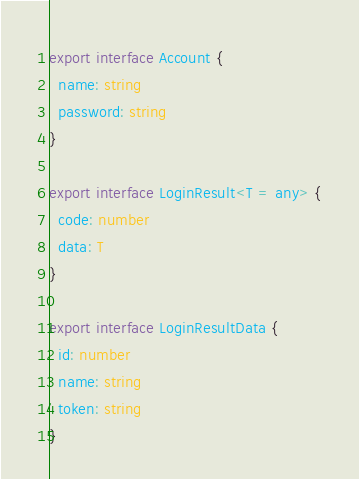Convert code to text. <code><loc_0><loc_0><loc_500><loc_500><_TypeScript_>export interface Account {
  name: string
  password: string
}

export interface LoginResult<T = any> {
  code: number
  data: T
}

export interface LoginResultData {
  id: number
  name: string
  token: string
}
</code> 